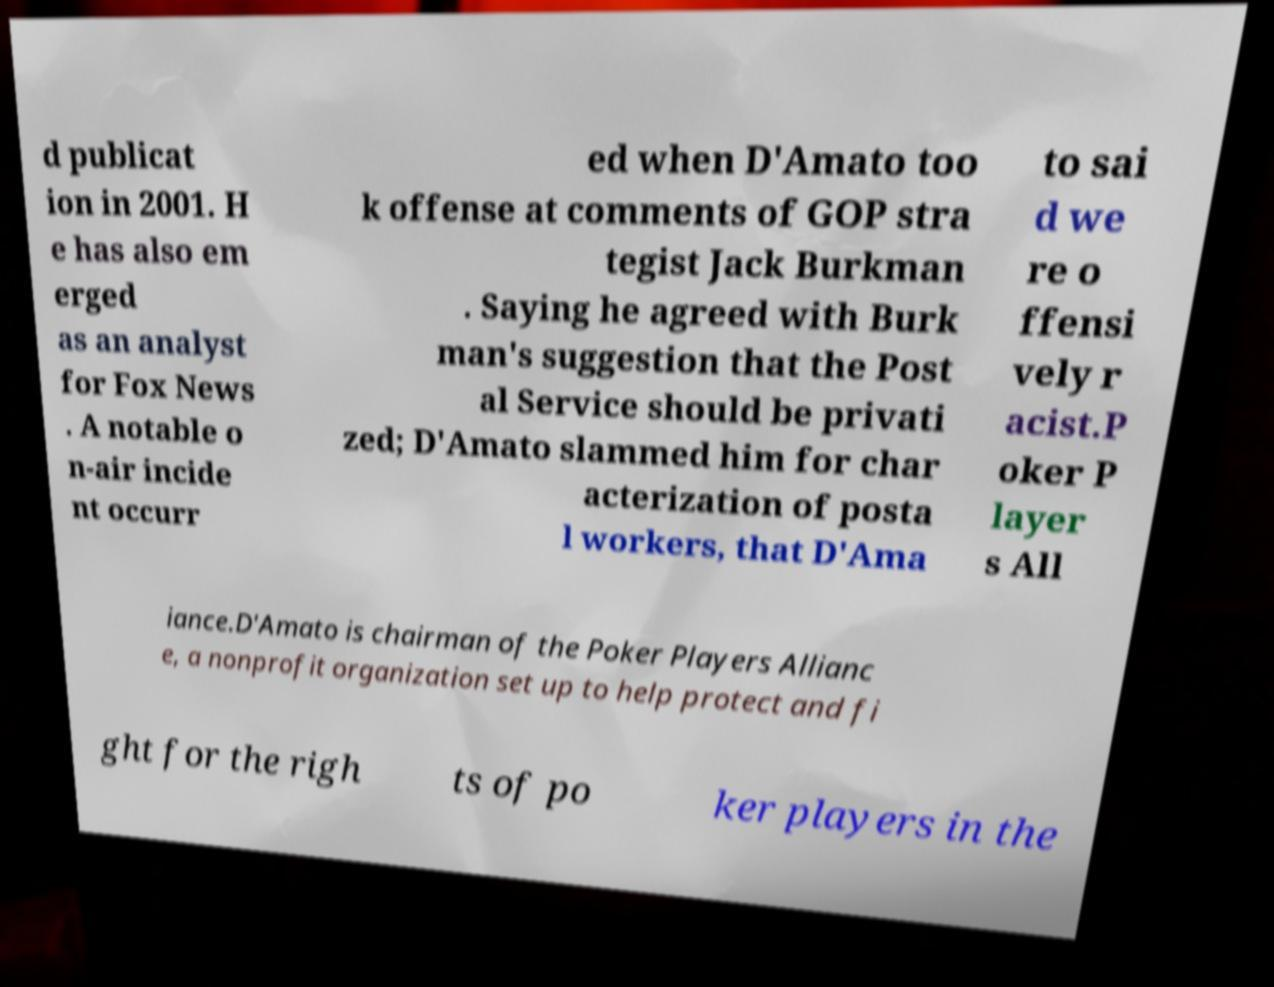For documentation purposes, I need the text within this image transcribed. Could you provide that? d publicat ion in 2001. H e has also em erged as an analyst for Fox News . A notable o n-air incide nt occurr ed when D'Amato too k offense at comments of GOP stra tegist Jack Burkman . Saying he agreed with Burk man's suggestion that the Post al Service should be privati zed; D'Amato slammed him for char acterization of posta l workers, that D'Ama to sai d we re o ffensi vely r acist.P oker P layer s All iance.D'Amato is chairman of the Poker Players Allianc e, a nonprofit organization set up to help protect and fi ght for the righ ts of po ker players in the 